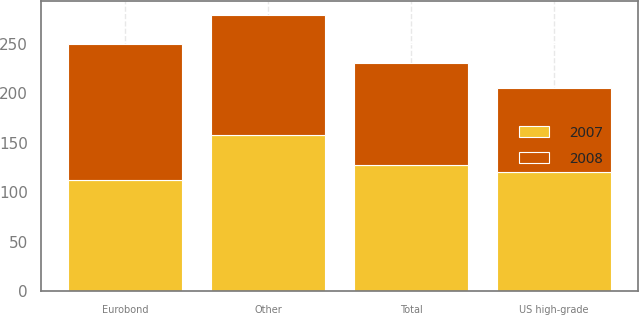Convert chart to OTSL. <chart><loc_0><loc_0><loc_500><loc_500><stacked_bar_chart><ecel><fcel>US high-grade<fcel>Eurobond<fcel>Other<fcel>Total<nl><fcel>2007<fcel>121<fcel>112<fcel>158<fcel>128<nl><fcel>2008<fcel>84<fcel>138<fcel>121<fcel>103<nl></chart> 